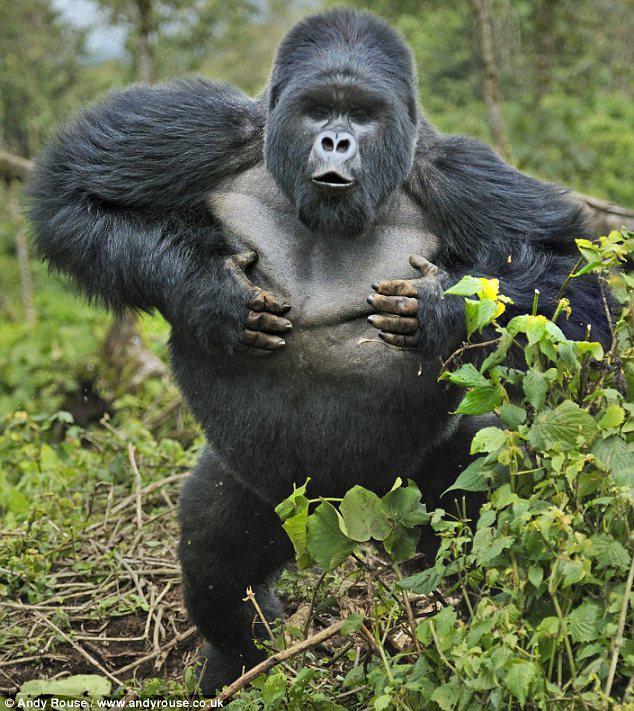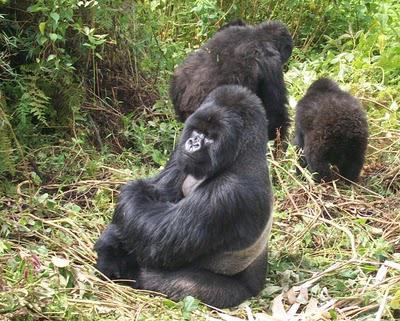The first image is the image on the left, the second image is the image on the right. Examine the images to the left and right. Is the description "There are no more than four monkeys." accurate? Answer yes or no. Yes. The first image is the image on the left, the second image is the image on the right. Assess this claim about the two images: "There are no more than two baby gorillas in both images.". Correct or not? Answer yes or no. No. 